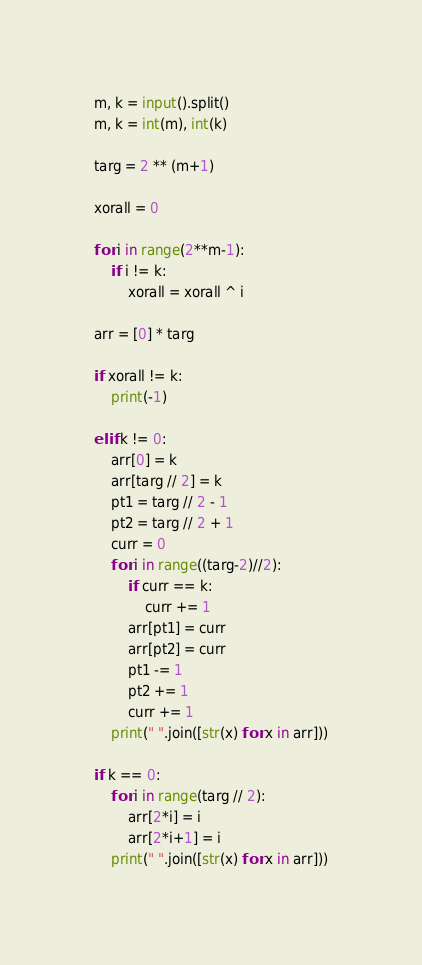Convert code to text. <code><loc_0><loc_0><loc_500><loc_500><_Python_>m, k = input().split()
m, k = int(m), int(k)

targ = 2 ** (m+1)

xorall = 0

for i in range(2**m-1):
    if i != k:
        xorall = xorall ^ i

arr = [0] * targ

if xorall != k:
    print(-1)

elif k != 0:
    arr[0] = k
    arr[targ // 2] = k
    pt1 = targ // 2 - 1
    pt2 = targ // 2 + 1
    curr = 0
    for i in range((targ-2)//2):
        if curr == k:
            curr += 1
        arr[pt1] = curr
        arr[pt2] = curr
        pt1 -= 1
        pt2 += 1
        curr += 1  
    print(" ".join([str(x) for x in arr]))
        
if k == 0:
    for i in range(targ // 2):
        arr[2*i] = i
        arr[2*i+1] = i
    print(" ".join([str(x) for x in arr]))
</code> 